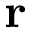Convert formula to latex. <formula><loc_0><loc_0><loc_500><loc_500>r</formula> 